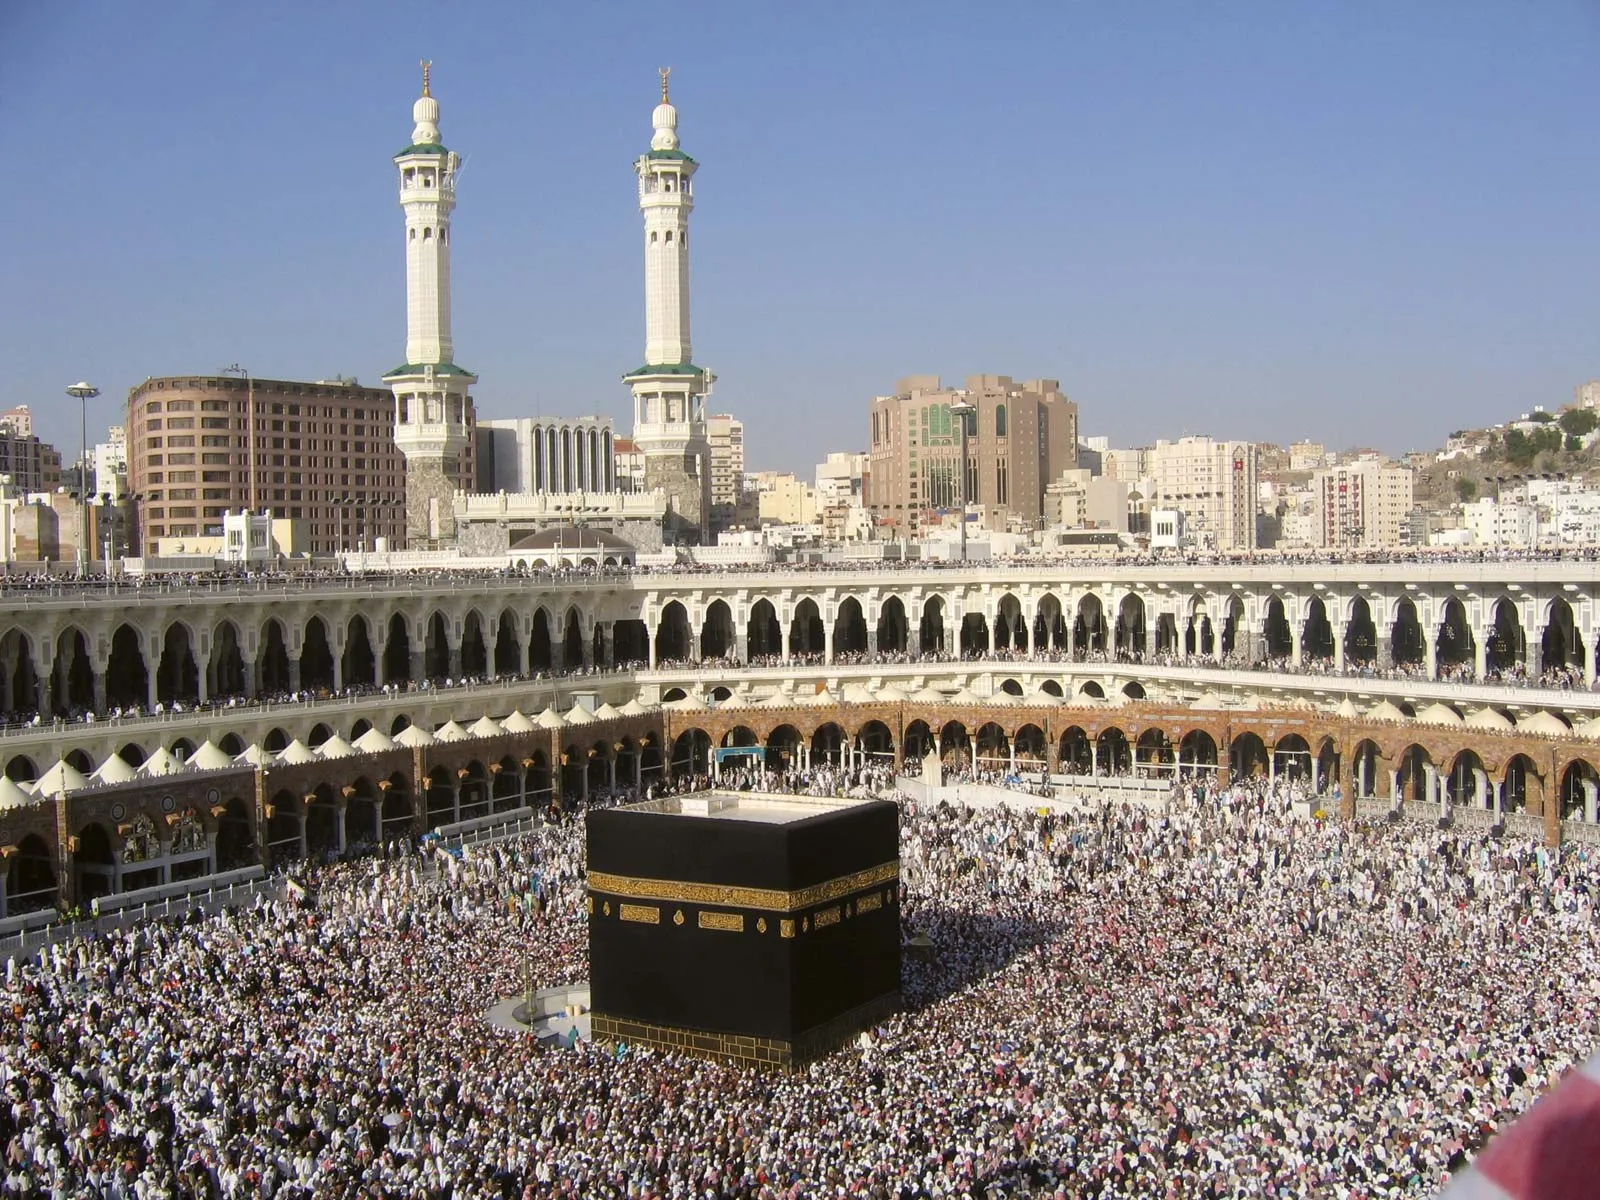What do you think is going on in this snapshot?
 The image captures a breathtaking view of the Kaaba, the most sacred site in Islam, located in Mecca, Saudi Arabia. From a high vantage point, the Kaaba stands out as a large, imposing cube draped in black cloth with gold accents, radiating a sense of reverence and awe. The area surrounding the Kaaba is teeming with a sea of people, all dressed in white, their figures forming a stark contrast against the blackness of the Kaaba. The crowd appears to be in a state of constant motion, their movements reflecting the ritual of Tawaf, where pilgrims circumambulate the Kaaba in a counterclockwise direction. In the background, two tall minarets rise into the sky, their slender forms a testament to Islamic architectural prowess. These minarets, along with several other buildings, add depth to the scene, creating a blend of the ancient and the modern. The overall image paints a picture of devotion, unity, and the enduring significance of this holy site. 